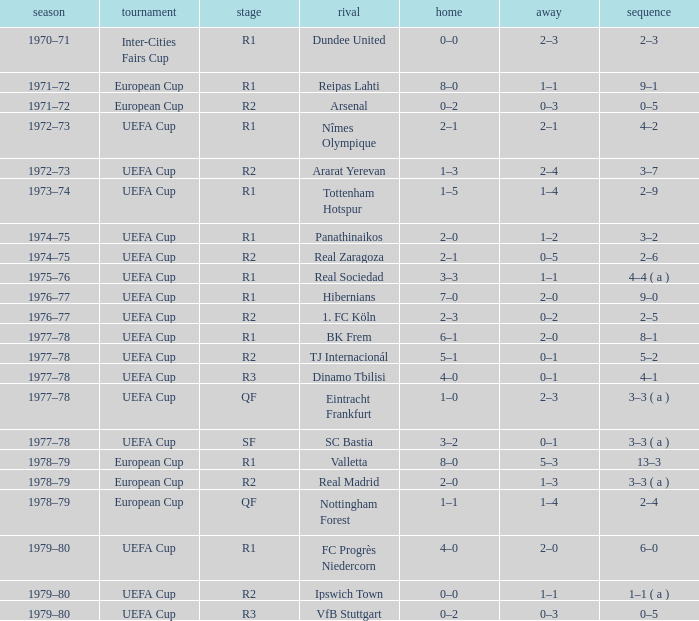Which Opponent has an Away of 1–1, and a Home of 3–3? Real Sociedad. 